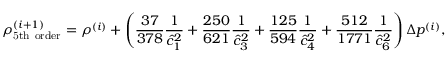<formula> <loc_0><loc_0><loc_500><loc_500>\rho _ { 5 t h o r d e r } ^ { ( i + 1 ) } = \rho ^ { ( i ) } + \left ( \frac { 3 7 } { 3 7 8 } \frac { 1 } { \hat { c } _ { 1 } ^ { 2 } } + \frac { 2 5 0 } { 6 2 1 } \frac { 1 } { \hat { c } _ { 3 } ^ { 2 } } + \frac { 1 2 5 } { 5 9 4 } \frac { 1 } { \hat { c } _ { 4 } ^ { 2 } } + \frac { 5 1 2 } { 1 7 7 1 } \frac { 1 } { \hat { c } _ { 6 } ^ { 2 } } \right ) \Delta p ^ { ( i ) } ,</formula> 